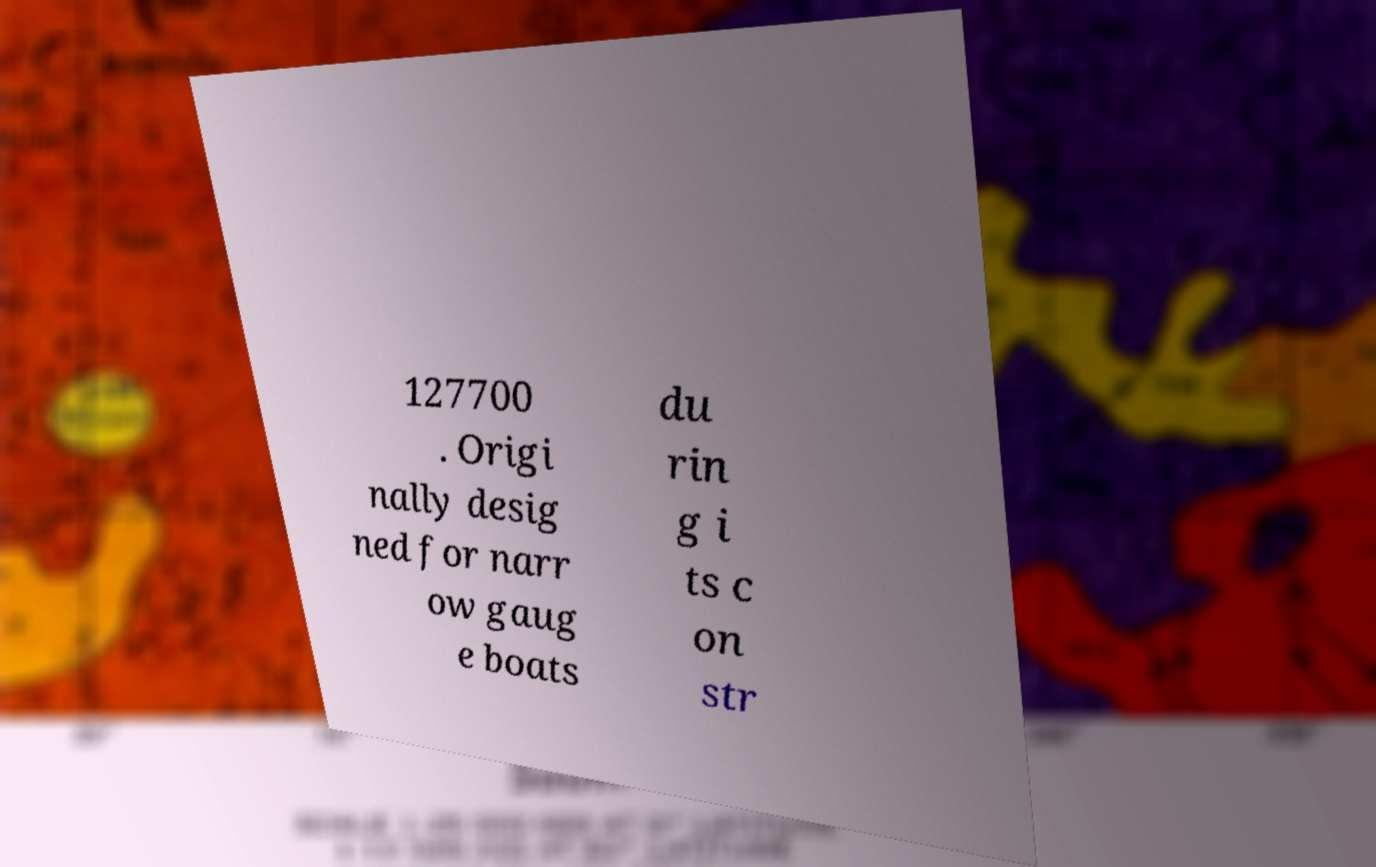I need the written content from this picture converted into text. Can you do that? 127700 . Origi nally desig ned for narr ow gaug e boats du rin g i ts c on str 